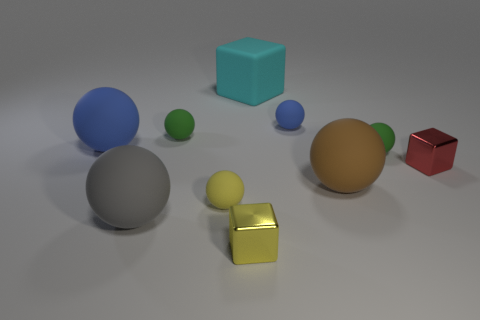Subtract all gray balls. How many balls are left? 6 Subtract 4 spheres. How many spheres are left? 3 Subtract all big balls. How many balls are left? 4 Subtract all red balls. Subtract all green cylinders. How many balls are left? 7 Subtract all balls. How many objects are left? 3 Subtract all blue matte things. Subtract all tiny yellow matte objects. How many objects are left? 7 Add 1 tiny yellow metallic cubes. How many tiny yellow metallic cubes are left? 2 Add 6 tiny purple cubes. How many tiny purple cubes exist? 6 Subtract 0 purple balls. How many objects are left? 10 